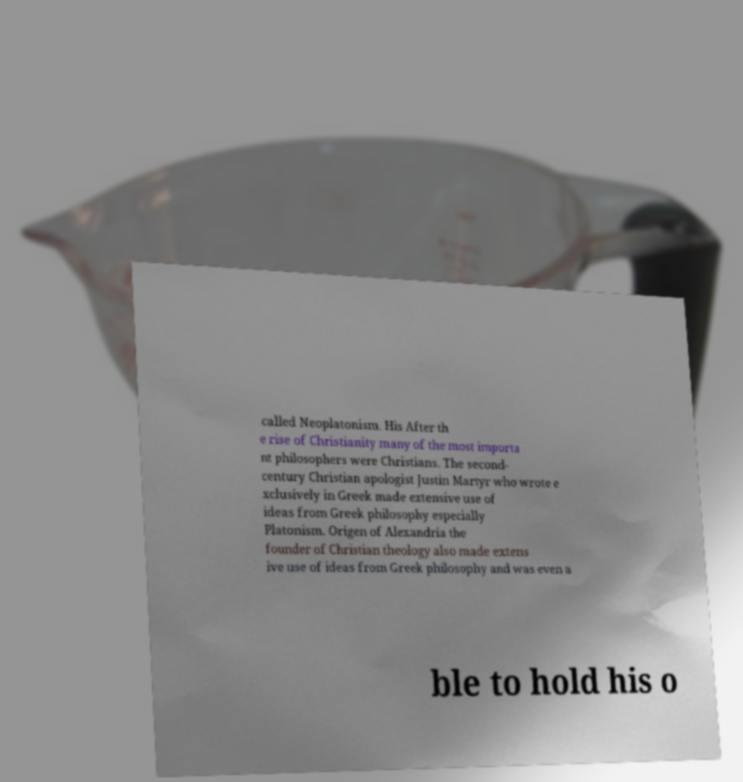Can you read and provide the text displayed in the image?This photo seems to have some interesting text. Can you extract and type it out for me? called Neoplatonism. His After th e rise of Christianity many of the most importa nt philosophers were Christians. The second- century Christian apologist Justin Martyr who wrote e xclusively in Greek made extensive use of ideas from Greek philosophy especially Platonism. Origen of Alexandria the founder of Christian theology also made extens ive use of ideas from Greek philosophy and was even a ble to hold his o 